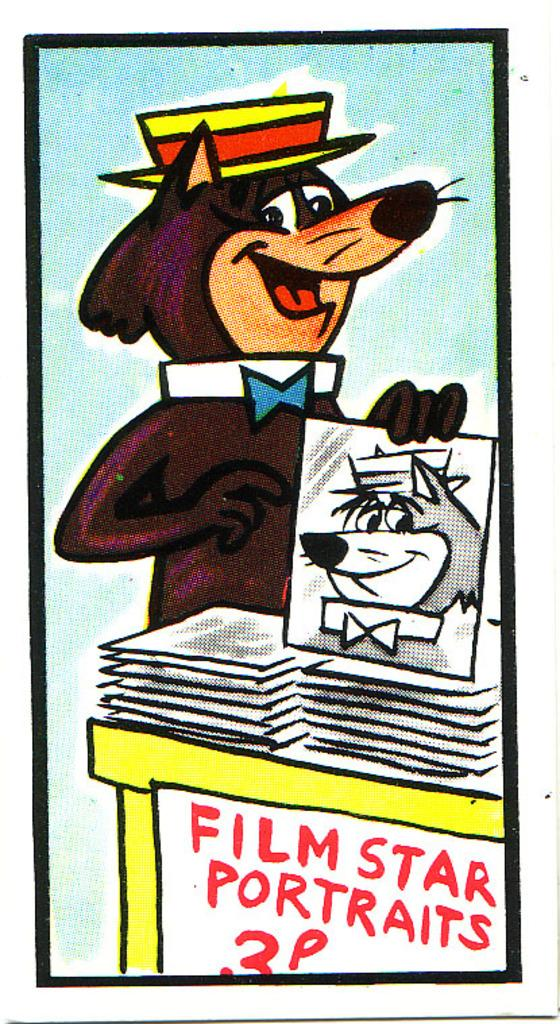<image>
Present a compact description of the photo's key features. A cartoon animal is trying to sell pictures of himself for 3 p. 